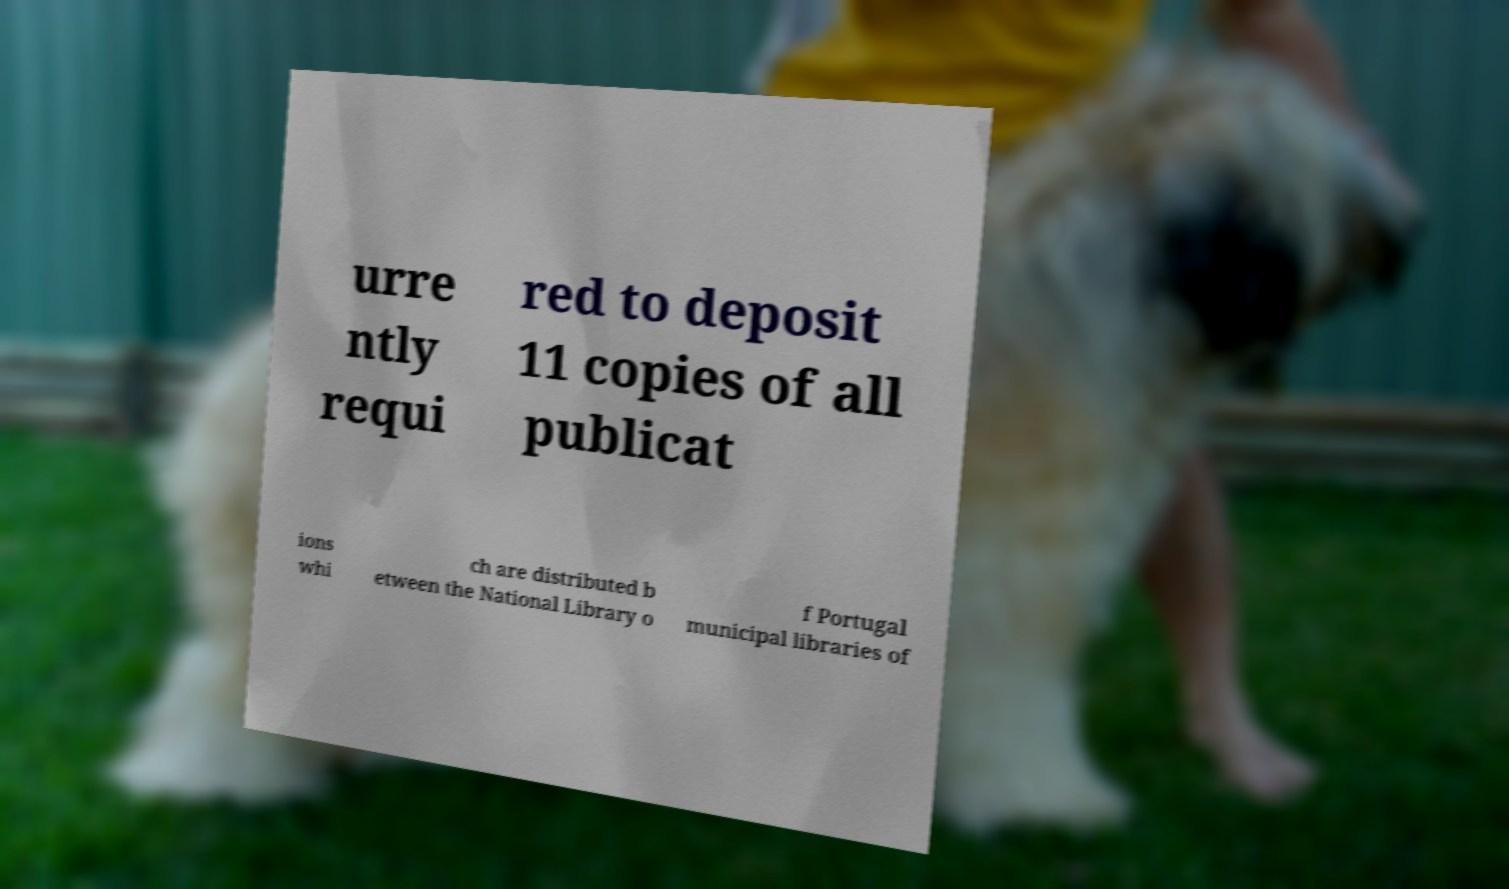Could you extract and type out the text from this image? urre ntly requi red to deposit 11 copies of all publicat ions whi ch are distributed b etween the National Library o f Portugal municipal libraries of 